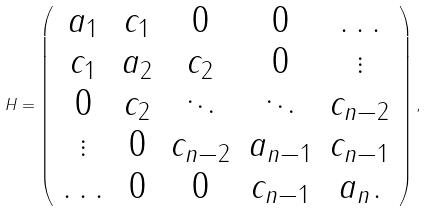<formula> <loc_0><loc_0><loc_500><loc_500>H = \left ( \begin{array} { c c c c c } a _ { 1 } & c _ { 1 } & 0 & 0 & \hdots \\ c _ { 1 } & a _ { 2 } & c _ { 2 } & 0 & \vdots \\ 0 & c _ { 2 } & \ddots & \ddots & c _ { n - 2 } \\ \vdots & 0 & c _ { n - 2 } & a _ { n - 1 } & c _ { n - 1 } \\ \hdots & 0 & 0 & c _ { n - 1 } & a _ { n } . \end{array} \right ) ,</formula> 